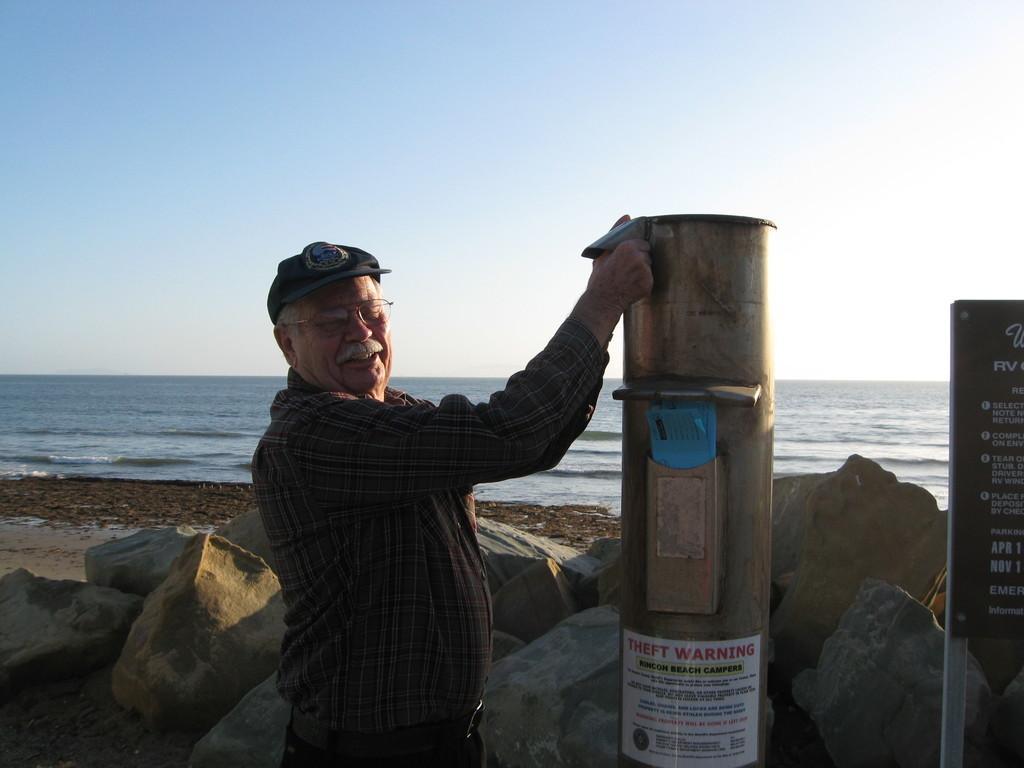Could you give a brief overview of what you see in this image? In this image I can see a person wearing shirt, cap and black color pant is standing and holding a metal object. I can see few rocks, a board and the ground. In the background I can see the water and the sky. 